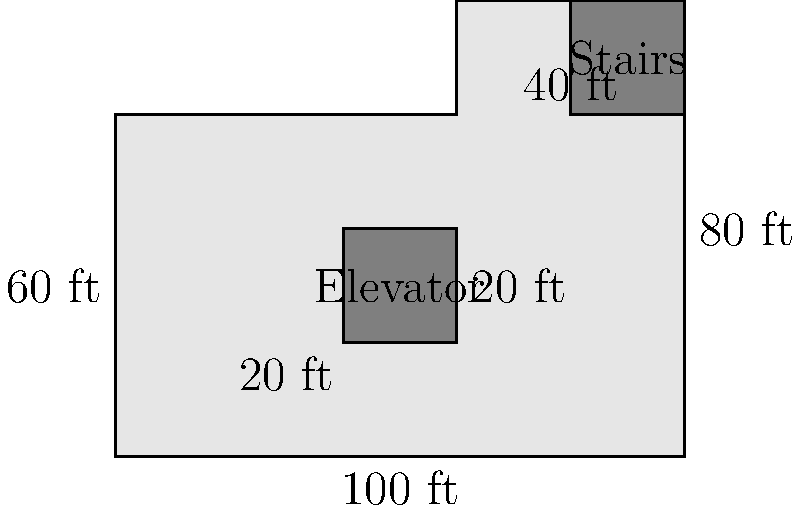Given the floor plan of an office building shown above, calculate the total rentable square footage. Assume that the elevator and stairwell areas are not included in the rentable space. To calculate the total rentable square footage, we need to follow these steps:

1. Calculate the total area of the floor plan:
   $$(100 \text{ ft} \times 60 \text{ ft}) + (40 \text{ ft} \times 20 \text{ ft}) = 6000 \text{ sq ft} + 800 \text{ sq ft} = 6800 \text{ sq ft}$$

2. Calculate the area of the elevator:
   $$20 \text{ ft} \times 20 \text{ ft} = 400 \text{ sq ft}$$

3. Calculate the area of the stairs:
   $$20 \text{ ft} \times 20 \text{ ft} = 400 \text{ sq ft}$$

4. Subtract the non-rentable areas (elevator and stairs) from the total area:
   $$6800 \text{ sq ft} - (400 \text{ sq ft} + 400 \text{ sq ft}) = 6000 \text{ sq ft}$$

Therefore, the total rentable square footage of the office building is 6000 sq ft.
Answer: 6000 sq ft 